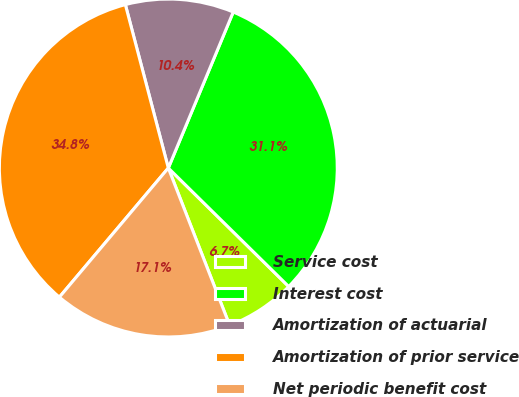Convert chart to OTSL. <chart><loc_0><loc_0><loc_500><loc_500><pie_chart><fcel>Service cost<fcel>Interest cost<fcel>Amortization of actuarial<fcel>Amortization of prior service<fcel>Net periodic benefit cost<nl><fcel>6.71%<fcel>31.1%<fcel>10.37%<fcel>34.76%<fcel>17.07%<nl></chart> 